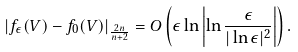<formula> <loc_0><loc_0><loc_500><loc_500>\left | f _ { \epsilon } ( V ) - f _ { 0 } ( V ) \right | _ { \frac { 2 n } { n + 2 } } = O \left ( \epsilon \ln \left | \ln \frac { \epsilon } { | \ln \epsilon | ^ { 2 } } \right | \right ) .</formula> 